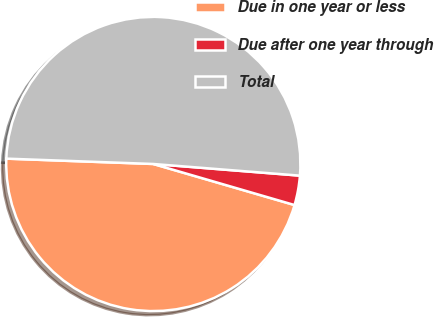<chart> <loc_0><loc_0><loc_500><loc_500><pie_chart><fcel>Due in one year or less<fcel>Due after one year through<fcel>Total<nl><fcel>46.08%<fcel>3.24%<fcel>50.69%<nl></chart> 